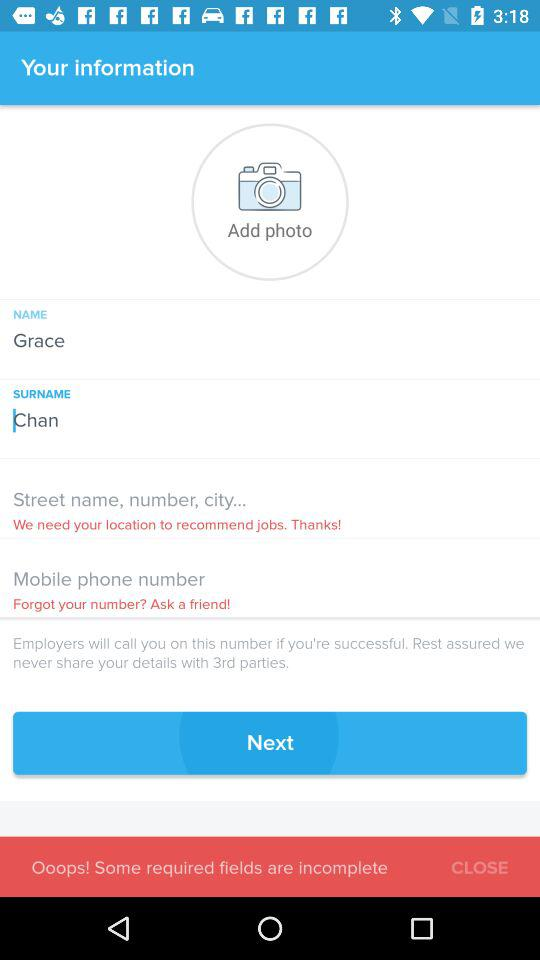What is the surname? The surname is Chan. 